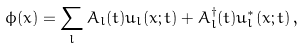Convert formula to latex. <formula><loc_0><loc_0><loc_500><loc_500>\phi ( x ) = \sum _ { l } A _ { l } ( t ) u _ { l } ( x ; t ) + A ^ { \dagger } _ { l } ( t ) u ^ { * } _ { l } ( x ; t ) \, ,</formula> 